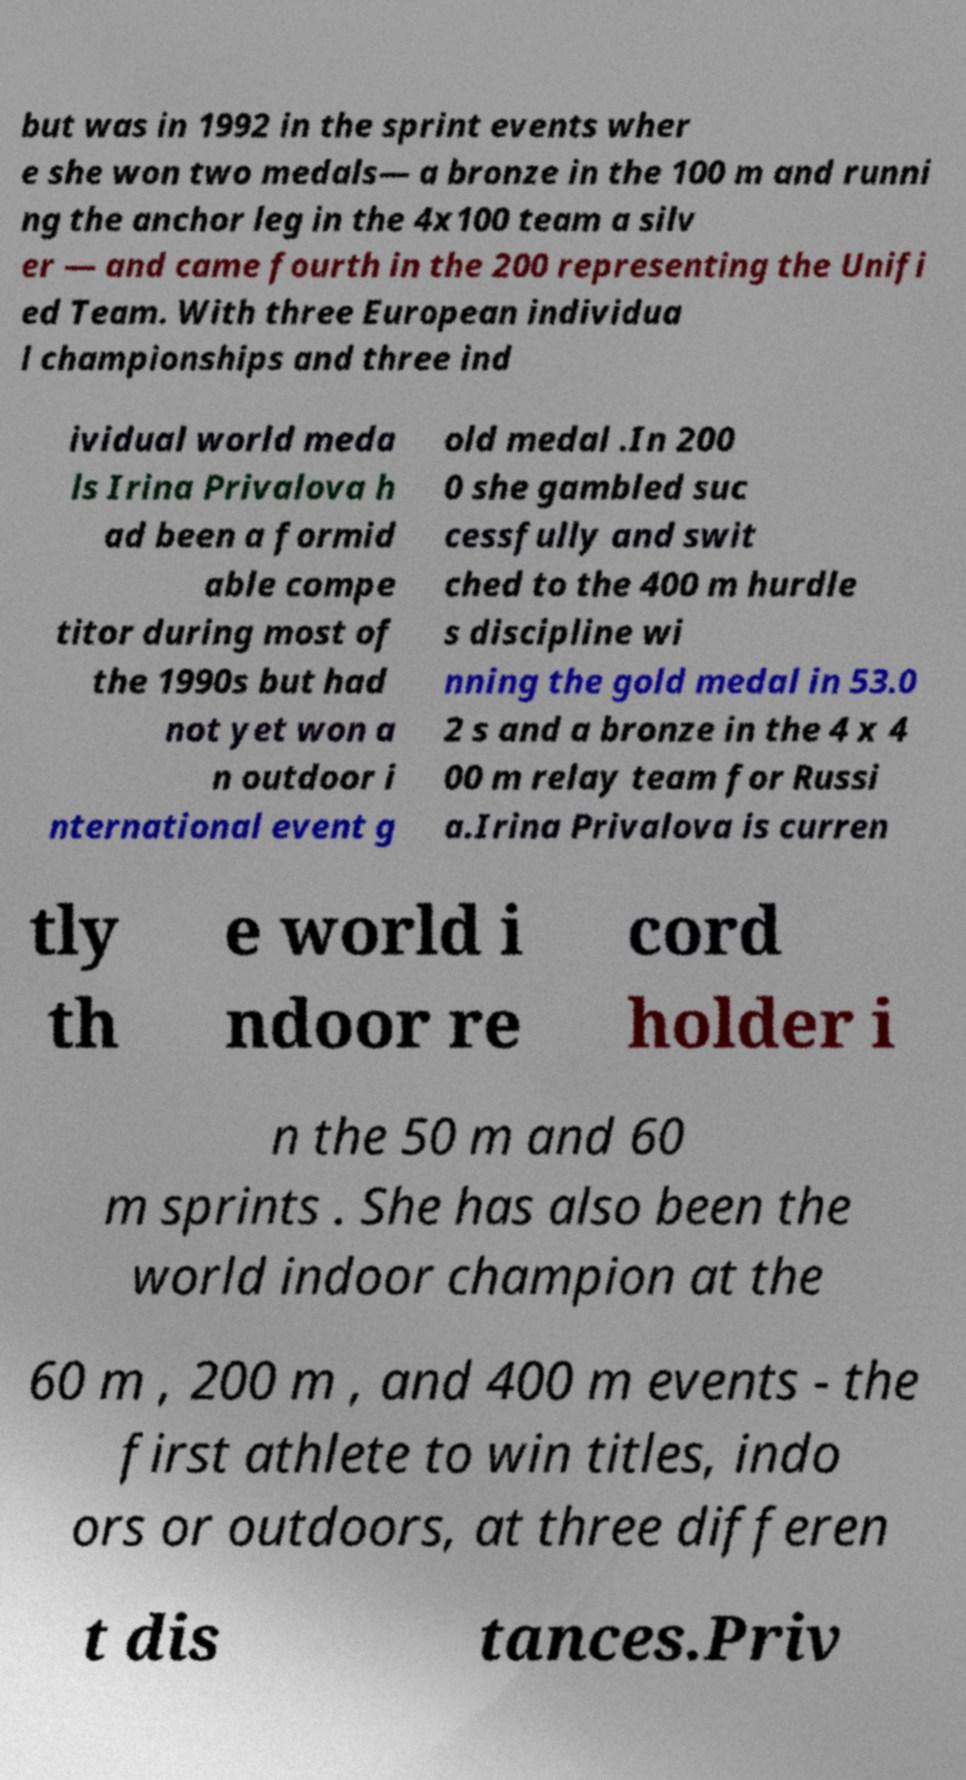Please identify and transcribe the text found in this image. but was in 1992 in the sprint events wher e she won two medals— a bronze in the 100 m and runni ng the anchor leg in the 4x100 team a silv er — and came fourth in the 200 representing the Unifi ed Team. With three European individua l championships and three ind ividual world meda ls Irina Privalova h ad been a formid able compe titor during most of the 1990s but had not yet won a n outdoor i nternational event g old medal .In 200 0 she gambled suc cessfully and swit ched to the 400 m hurdle s discipline wi nning the gold medal in 53.0 2 s and a bronze in the 4 x 4 00 m relay team for Russi a.Irina Privalova is curren tly th e world i ndoor re cord holder i n the 50 m and 60 m sprints . She has also been the world indoor champion at the 60 m , 200 m , and 400 m events - the first athlete to win titles, indo ors or outdoors, at three differen t dis tances.Priv 